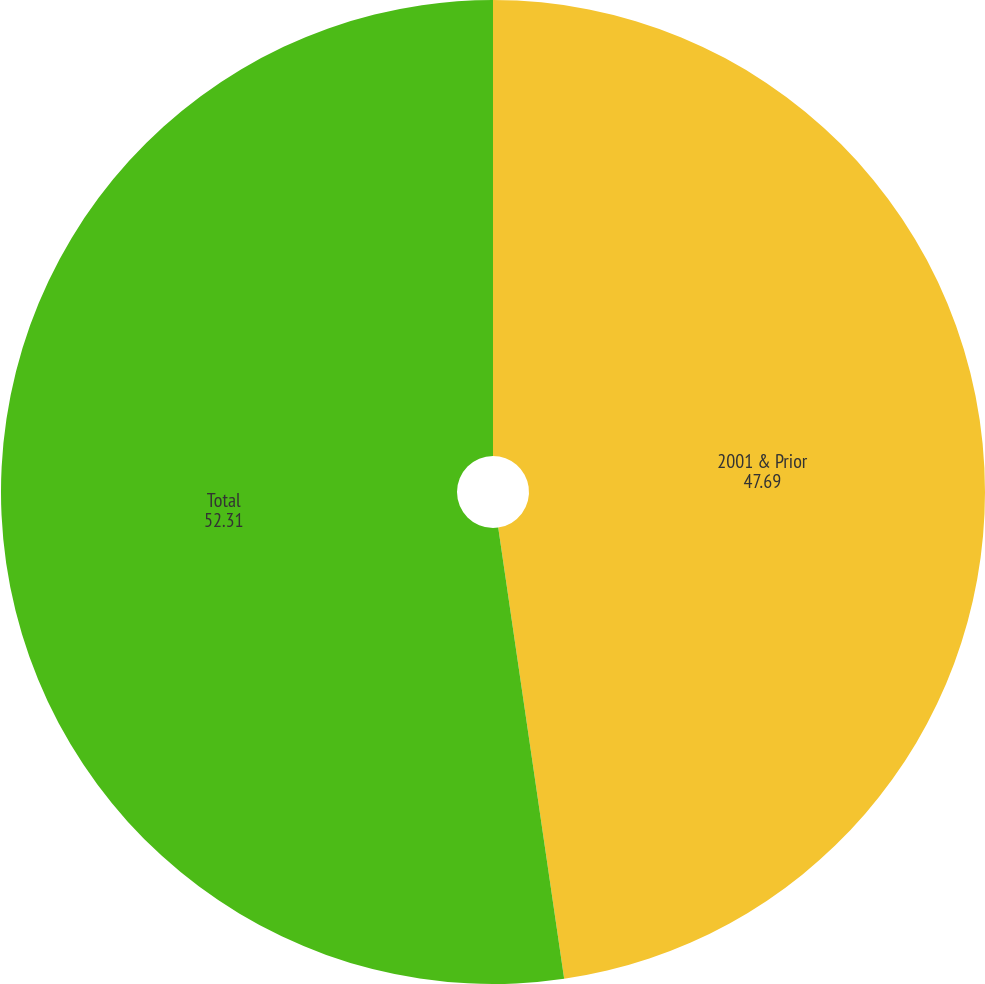<chart> <loc_0><loc_0><loc_500><loc_500><pie_chart><fcel>2001 & Prior<fcel>Total<nl><fcel>47.69%<fcel>52.31%<nl></chart> 